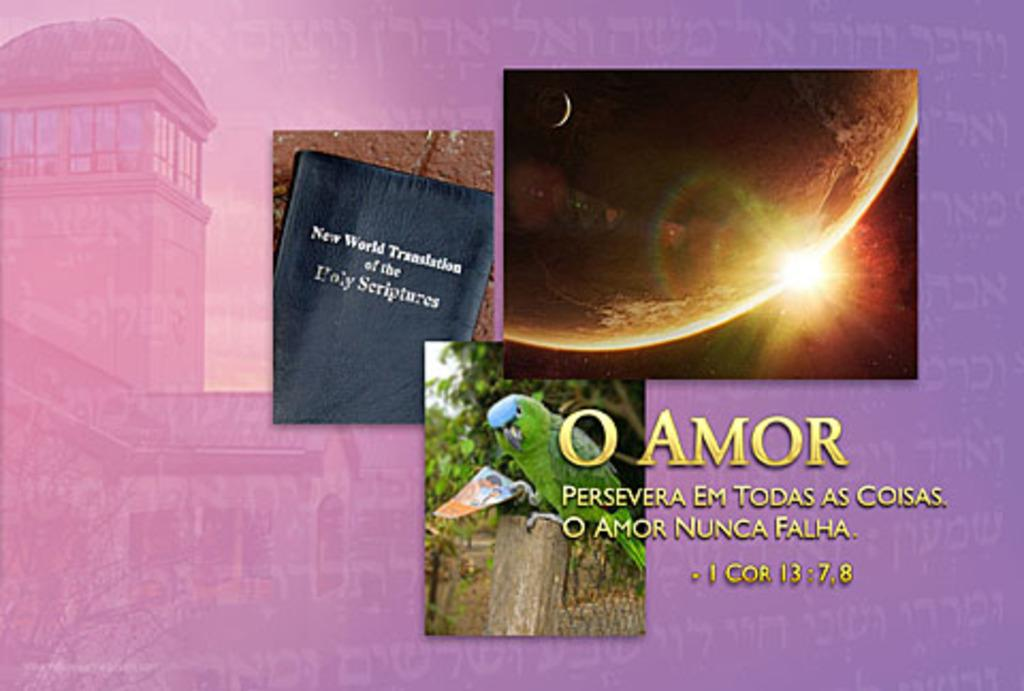<image>
Write a terse but informative summary of the picture. An ad that is for 'New World Translation of the Holy Scriptures'. 